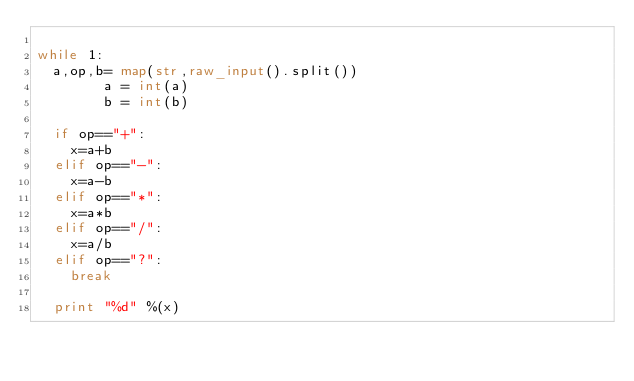Convert code to text. <code><loc_0><loc_0><loc_500><loc_500><_Python_>
while 1:
	a,op,b= map(str,raw_input().split())
        a = int(a)
        b = int(b)

	if op=="+":
		x=a+b
	elif op=="-":
		x=a-b
	elif op=="*":
		x=a*b
	elif op=="/":
		x=a/b
	elif op=="?":
		break
	
	print "%d" %(x)</code> 